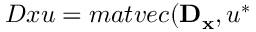<formula> <loc_0><loc_0><loc_500><loc_500>D x u = m a t v e c ( D _ { x } , u ^ { * }</formula> 